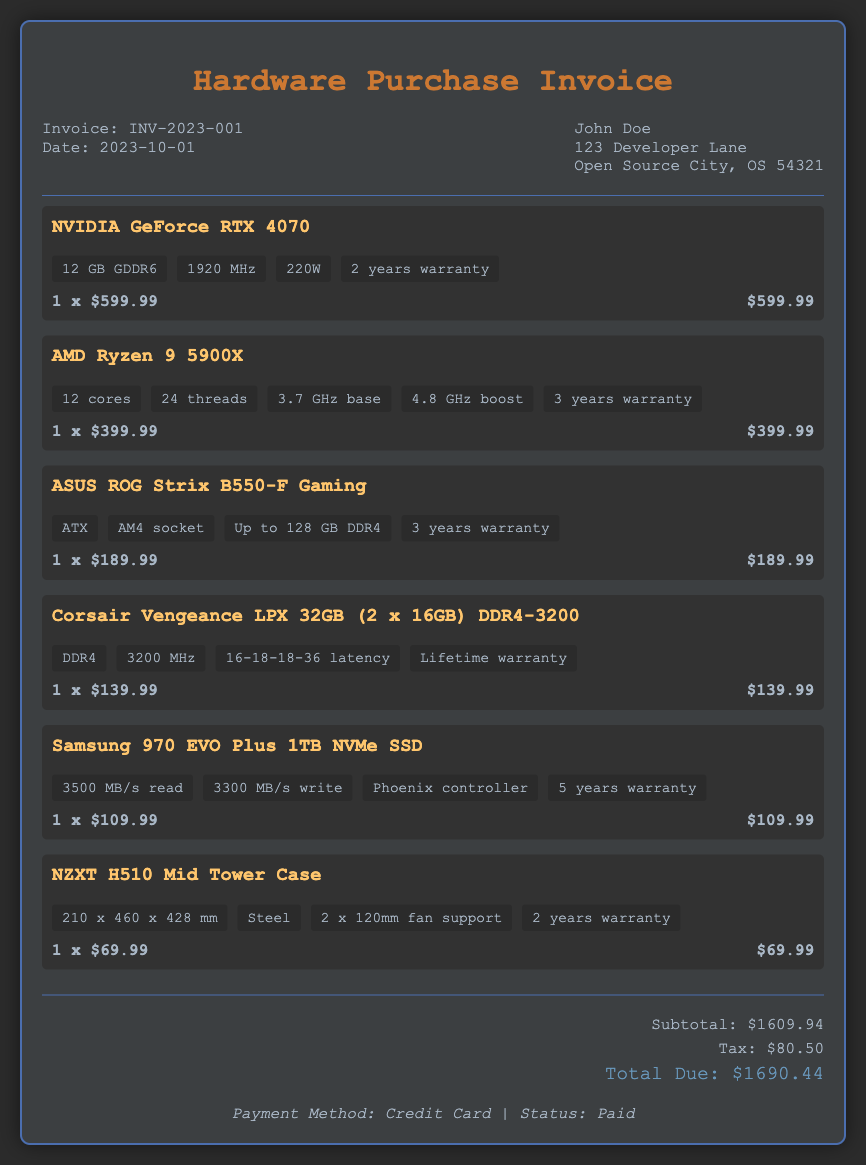what is the invoice number? The invoice number is stated prominently in the document for easy identification.
Answer: INV-2023-001 what is the date of the invoice? The document specifies the date of the invoice, which is essential for record-keeping.
Answer: 2023-10-01 how many total items were purchased? By counting the individual items listed in the purchase details, we can determine the quantity.
Answer: 6 what is the warranty duration for the NVIDIA GeForce RTX 4070? The warranty information for each component is part of the specifications in the document.
Answer: 2 years what was the subtotal of the purchase? This value is calculated from the individual costs of all items before tax.
Answer: $1609.94 what payment method was used? The document indicates the payment method used for the transaction towards the end.
Answer: Credit Card what is the total amount due? Total due is the final amount after adding tax to the subtotal and is highlighted in the document.
Answer: $1690.44 what is the warranty duration for the Samsung 970 EVO Plus? Warranty details for each component are clearly mentioned under their respective specifications.
Answer: 5 years what is the cost of the Corsair Vengeance LPX? The cost is clearly displayed next to the item listed.
Answer: $139.99 